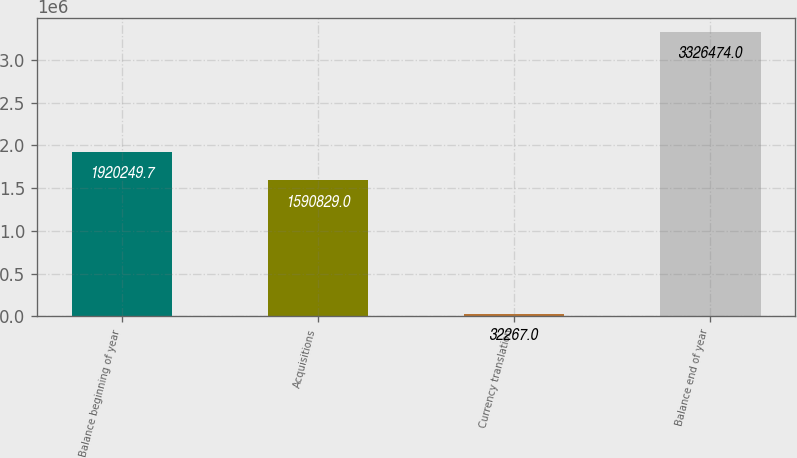<chart> <loc_0><loc_0><loc_500><loc_500><bar_chart><fcel>Balance beginning of year<fcel>Acquisitions<fcel>Currency translation<fcel>Balance end of year<nl><fcel>1.92025e+06<fcel>1.59083e+06<fcel>32267<fcel>3.32647e+06<nl></chart> 